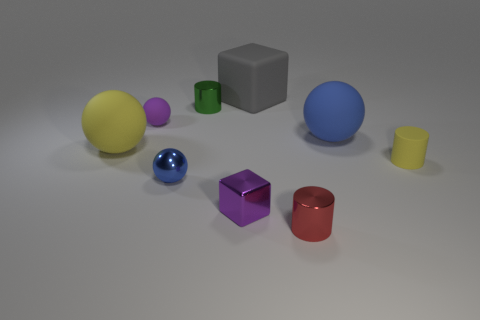Add 1 metal blocks. How many objects exist? 10 Subtract all balls. How many objects are left? 5 Add 8 tiny purple rubber balls. How many tiny purple rubber balls are left? 9 Add 7 tiny purple rubber balls. How many tiny purple rubber balls exist? 8 Subtract 1 red cylinders. How many objects are left? 8 Subtract all tiny matte spheres. Subtract all gray objects. How many objects are left? 7 